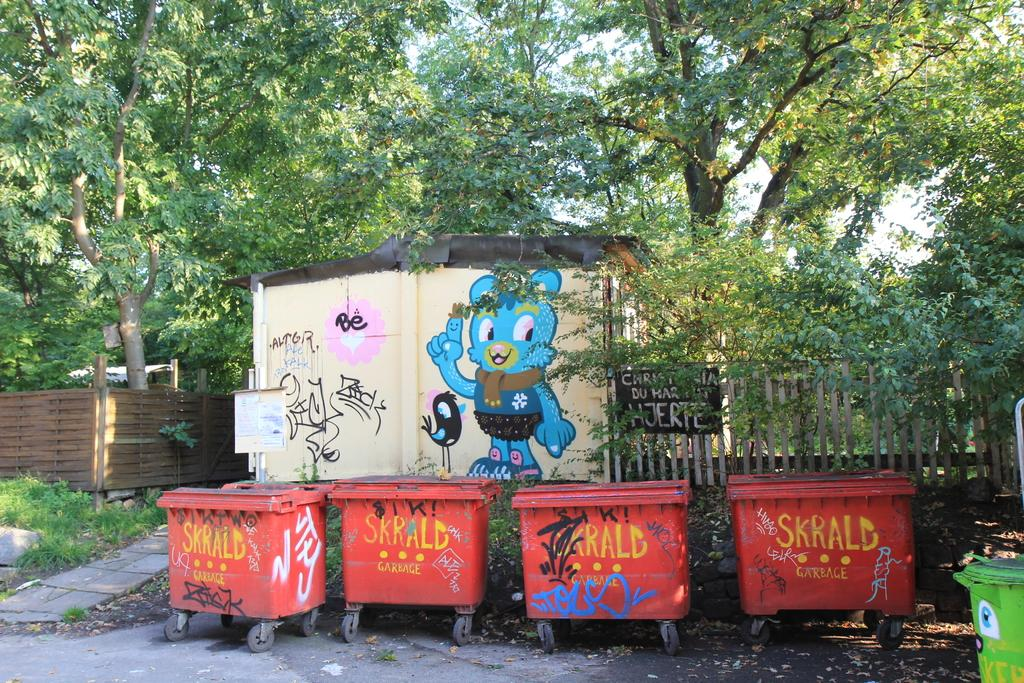<image>
Render a clear and concise summary of the photo. Four dumpsters lined up outside and next to a fence all have the name SKALD printed on them in yellow and they have graffiti all over them. 